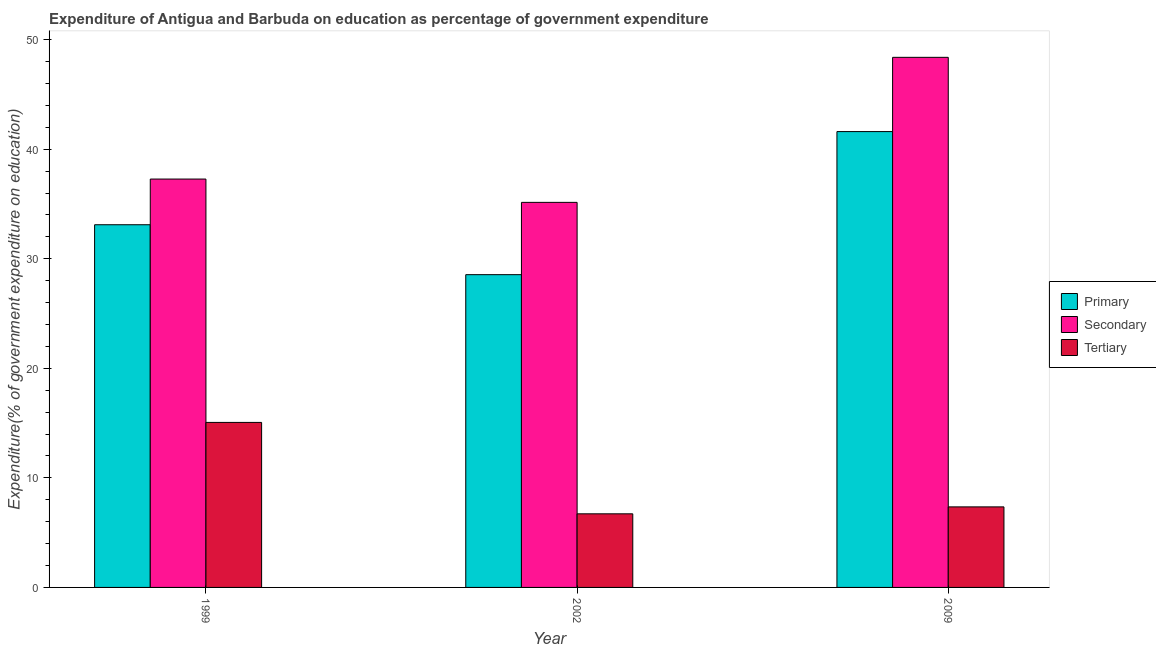How many different coloured bars are there?
Your response must be concise. 3. How many groups of bars are there?
Keep it short and to the point. 3. How many bars are there on the 2nd tick from the right?
Keep it short and to the point. 3. What is the label of the 2nd group of bars from the left?
Provide a succinct answer. 2002. In how many cases, is the number of bars for a given year not equal to the number of legend labels?
Offer a terse response. 0. What is the expenditure on secondary education in 1999?
Offer a very short reply. 37.28. Across all years, what is the maximum expenditure on tertiary education?
Your response must be concise. 15.06. Across all years, what is the minimum expenditure on tertiary education?
Your answer should be very brief. 6.72. In which year was the expenditure on secondary education maximum?
Provide a succinct answer. 2009. In which year was the expenditure on primary education minimum?
Offer a terse response. 2002. What is the total expenditure on primary education in the graph?
Offer a very short reply. 103.27. What is the difference between the expenditure on primary education in 1999 and that in 2002?
Keep it short and to the point. 4.56. What is the difference between the expenditure on primary education in 2002 and the expenditure on secondary education in 2009?
Make the answer very short. -13.06. What is the average expenditure on primary education per year?
Provide a succinct answer. 34.42. In how many years, is the expenditure on secondary education greater than 28 %?
Provide a succinct answer. 3. What is the ratio of the expenditure on tertiary education in 1999 to that in 2009?
Offer a very short reply. 2.05. Is the expenditure on tertiary education in 2002 less than that in 2009?
Your response must be concise. Yes. Is the difference between the expenditure on secondary education in 1999 and 2002 greater than the difference between the expenditure on primary education in 1999 and 2002?
Offer a very short reply. No. What is the difference between the highest and the second highest expenditure on tertiary education?
Offer a very short reply. 7.71. What is the difference between the highest and the lowest expenditure on tertiary education?
Make the answer very short. 8.34. Is the sum of the expenditure on tertiary education in 1999 and 2002 greater than the maximum expenditure on secondary education across all years?
Your response must be concise. Yes. What does the 3rd bar from the left in 2002 represents?
Ensure brevity in your answer.  Tertiary. What does the 3rd bar from the right in 1999 represents?
Your response must be concise. Primary. Is it the case that in every year, the sum of the expenditure on primary education and expenditure on secondary education is greater than the expenditure on tertiary education?
Make the answer very short. Yes. How many bars are there?
Ensure brevity in your answer.  9. Are the values on the major ticks of Y-axis written in scientific E-notation?
Offer a terse response. No. Does the graph contain grids?
Offer a terse response. No. Where does the legend appear in the graph?
Your response must be concise. Center right. What is the title of the graph?
Offer a very short reply. Expenditure of Antigua and Barbuda on education as percentage of government expenditure. What is the label or title of the Y-axis?
Offer a terse response. Expenditure(% of government expenditure on education). What is the Expenditure(% of government expenditure on education) of Primary in 1999?
Offer a terse response. 33.11. What is the Expenditure(% of government expenditure on education) in Secondary in 1999?
Keep it short and to the point. 37.28. What is the Expenditure(% of government expenditure on education) in Tertiary in 1999?
Provide a succinct answer. 15.06. What is the Expenditure(% of government expenditure on education) in Primary in 2002?
Offer a very short reply. 28.55. What is the Expenditure(% of government expenditure on education) of Secondary in 2002?
Keep it short and to the point. 35.15. What is the Expenditure(% of government expenditure on education) in Tertiary in 2002?
Provide a short and direct response. 6.72. What is the Expenditure(% of government expenditure on education) in Primary in 2009?
Give a very brief answer. 41.61. What is the Expenditure(% of government expenditure on education) of Secondary in 2009?
Keep it short and to the point. 48.39. What is the Expenditure(% of government expenditure on education) of Tertiary in 2009?
Make the answer very short. 7.35. Across all years, what is the maximum Expenditure(% of government expenditure on education) of Primary?
Your response must be concise. 41.61. Across all years, what is the maximum Expenditure(% of government expenditure on education) of Secondary?
Offer a very short reply. 48.39. Across all years, what is the maximum Expenditure(% of government expenditure on education) of Tertiary?
Your answer should be very brief. 15.06. Across all years, what is the minimum Expenditure(% of government expenditure on education) in Primary?
Your response must be concise. 28.55. Across all years, what is the minimum Expenditure(% of government expenditure on education) of Secondary?
Offer a very short reply. 35.15. Across all years, what is the minimum Expenditure(% of government expenditure on education) of Tertiary?
Your answer should be compact. 6.72. What is the total Expenditure(% of government expenditure on education) of Primary in the graph?
Your answer should be compact. 103.27. What is the total Expenditure(% of government expenditure on education) of Secondary in the graph?
Offer a terse response. 120.83. What is the total Expenditure(% of government expenditure on education) of Tertiary in the graph?
Provide a succinct answer. 29.14. What is the difference between the Expenditure(% of government expenditure on education) in Primary in 1999 and that in 2002?
Offer a very short reply. 4.56. What is the difference between the Expenditure(% of government expenditure on education) of Secondary in 1999 and that in 2002?
Offer a terse response. 2.13. What is the difference between the Expenditure(% of government expenditure on education) of Tertiary in 1999 and that in 2002?
Your response must be concise. 8.34. What is the difference between the Expenditure(% of government expenditure on education) of Primary in 1999 and that in 2009?
Ensure brevity in your answer.  -8.5. What is the difference between the Expenditure(% of government expenditure on education) of Secondary in 1999 and that in 2009?
Give a very brief answer. -11.11. What is the difference between the Expenditure(% of government expenditure on education) in Tertiary in 1999 and that in 2009?
Make the answer very short. 7.71. What is the difference between the Expenditure(% of government expenditure on education) in Primary in 2002 and that in 2009?
Your answer should be very brief. -13.06. What is the difference between the Expenditure(% of government expenditure on education) of Secondary in 2002 and that in 2009?
Offer a terse response. -13.24. What is the difference between the Expenditure(% of government expenditure on education) in Tertiary in 2002 and that in 2009?
Your answer should be very brief. -0.63. What is the difference between the Expenditure(% of government expenditure on education) of Primary in 1999 and the Expenditure(% of government expenditure on education) of Secondary in 2002?
Offer a very short reply. -2.04. What is the difference between the Expenditure(% of government expenditure on education) in Primary in 1999 and the Expenditure(% of government expenditure on education) in Tertiary in 2002?
Provide a succinct answer. 26.39. What is the difference between the Expenditure(% of government expenditure on education) in Secondary in 1999 and the Expenditure(% of government expenditure on education) in Tertiary in 2002?
Make the answer very short. 30.56. What is the difference between the Expenditure(% of government expenditure on education) of Primary in 1999 and the Expenditure(% of government expenditure on education) of Secondary in 2009?
Give a very brief answer. -15.28. What is the difference between the Expenditure(% of government expenditure on education) of Primary in 1999 and the Expenditure(% of government expenditure on education) of Tertiary in 2009?
Provide a succinct answer. 25.76. What is the difference between the Expenditure(% of government expenditure on education) in Secondary in 1999 and the Expenditure(% of government expenditure on education) in Tertiary in 2009?
Your answer should be very brief. 29.93. What is the difference between the Expenditure(% of government expenditure on education) in Primary in 2002 and the Expenditure(% of government expenditure on education) in Secondary in 2009?
Your answer should be very brief. -19.84. What is the difference between the Expenditure(% of government expenditure on education) in Primary in 2002 and the Expenditure(% of government expenditure on education) in Tertiary in 2009?
Keep it short and to the point. 21.2. What is the difference between the Expenditure(% of government expenditure on education) of Secondary in 2002 and the Expenditure(% of government expenditure on education) of Tertiary in 2009?
Offer a terse response. 27.8. What is the average Expenditure(% of government expenditure on education) in Primary per year?
Your answer should be compact. 34.42. What is the average Expenditure(% of government expenditure on education) in Secondary per year?
Your answer should be compact. 40.28. What is the average Expenditure(% of government expenditure on education) of Tertiary per year?
Offer a very short reply. 9.71. In the year 1999, what is the difference between the Expenditure(% of government expenditure on education) in Primary and Expenditure(% of government expenditure on education) in Secondary?
Provide a succinct answer. -4.17. In the year 1999, what is the difference between the Expenditure(% of government expenditure on education) in Primary and Expenditure(% of government expenditure on education) in Tertiary?
Your answer should be very brief. 18.05. In the year 1999, what is the difference between the Expenditure(% of government expenditure on education) of Secondary and Expenditure(% of government expenditure on education) of Tertiary?
Make the answer very short. 22.22. In the year 2002, what is the difference between the Expenditure(% of government expenditure on education) of Primary and Expenditure(% of government expenditure on education) of Secondary?
Your answer should be compact. -6.6. In the year 2002, what is the difference between the Expenditure(% of government expenditure on education) of Primary and Expenditure(% of government expenditure on education) of Tertiary?
Give a very brief answer. 21.83. In the year 2002, what is the difference between the Expenditure(% of government expenditure on education) in Secondary and Expenditure(% of government expenditure on education) in Tertiary?
Ensure brevity in your answer.  28.43. In the year 2009, what is the difference between the Expenditure(% of government expenditure on education) of Primary and Expenditure(% of government expenditure on education) of Secondary?
Your response must be concise. -6.78. In the year 2009, what is the difference between the Expenditure(% of government expenditure on education) of Primary and Expenditure(% of government expenditure on education) of Tertiary?
Your answer should be compact. 34.26. In the year 2009, what is the difference between the Expenditure(% of government expenditure on education) in Secondary and Expenditure(% of government expenditure on education) in Tertiary?
Give a very brief answer. 41.04. What is the ratio of the Expenditure(% of government expenditure on education) in Primary in 1999 to that in 2002?
Your answer should be compact. 1.16. What is the ratio of the Expenditure(% of government expenditure on education) of Secondary in 1999 to that in 2002?
Provide a short and direct response. 1.06. What is the ratio of the Expenditure(% of government expenditure on education) of Tertiary in 1999 to that in 2002?
Provide a short and direct response. 2.24. What is the ratio of the Expenditure(% of government expenditure on education) in Primary in 1999 to that in 2009?
Keep it short and to the point. 0.8. What is the ratio of the Expenditure(% of government expenditure on education) of Secondary in 1999 to that in 2009?
Offer a very short reply. 0.77. What is the ratio of the Expenditure(% of government expenditure on education) of Tertiary in 1999 to that in 2009?
Make the answer very short. 2.05. What is the ratio of the Expenditure(% of government expenditure on education) of Primary in 2002 to that in 2009?
Make the answer very short. 0.69. What is the ratio of the Expenditure(% of government expenditure on education) of Secondary in 2002 to that in 2009?
Offer a very short reply. 0.73. What is the ratio of the Expenditure(% of government expenditure on education) of Tertiary in 2002 to that in 2009?
Give a very brief answer. 0.91. What is the difference between the highest and the second highest Expenditure(% of government expenditure on education) of Primary?
Your answer should be compact. 8.5. What is the difference between the highest and the second highest Expenditure(% of government expenditure on education) of Secondary?
Offer a very short reply. 11.11. What is the difference between the highest and the second highest Expenditure(% of government expenditure on education) of Tertiary?
Give a very brief answer. 7.71. What is the difference between the highest and the lowest Expenditure(% of government expenditure on education) in Primary?
Give a very brief answer. 13.06. What is the difference between the highest and the lowest Expenditure(% of government expenditure on education) in Secondary?
Make the answer very short. 13.24. What is the difference between the highest and the lowest Expenditure(% of government expenditure on education) of Tertiary?
Ensure brevity in your answer.  8.34. 